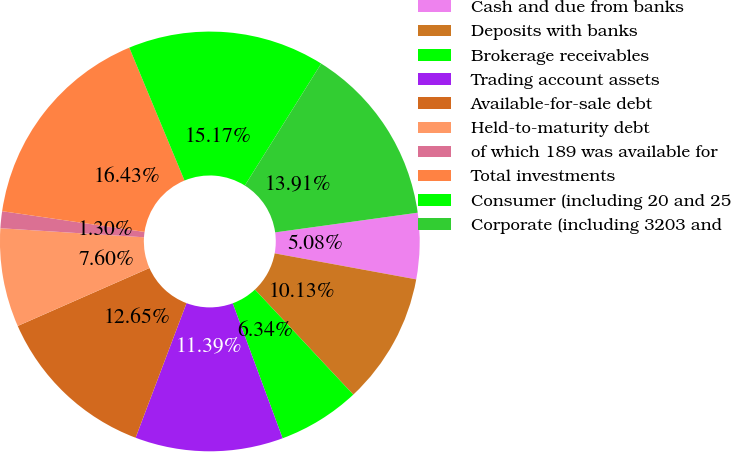<chart> <loc_0><loc_0><loc_500><loc_500><pie_chart><fcel>Cash and due from banks<fcel>Deposits with banks<fcel>Brokerage receivables<fcel>Trading account assets<fcel>Available-for-sale debt<fcel>Held-to-maturity debt<fcel>of which 189 was available for<fcel>Total investments<fcel>Consumer (including 20 and 25<fcel>Corporate (including 3203 and<nl><fcel>5.08%<fcel>10.13%<fcel>6.34%<fcel>11.39%<fcel>12.65%<fcel>7.6%<fcel>1.3%<fcel>16.43%<fcel>15.17%<fcel>13.91%<nl></chart> 